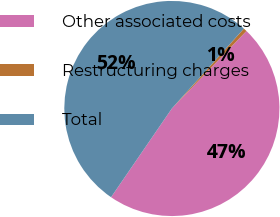Convert chart to OTSL. <chart><loc_0><loc_0><loc_500><loc_500><pie_chart><fcel>Other associated costs<fcel>Restructuring charges<fcel>Total<nl><fcel>47.37%<fcel>0.52%<fcel>52.11%<nl></chart> 